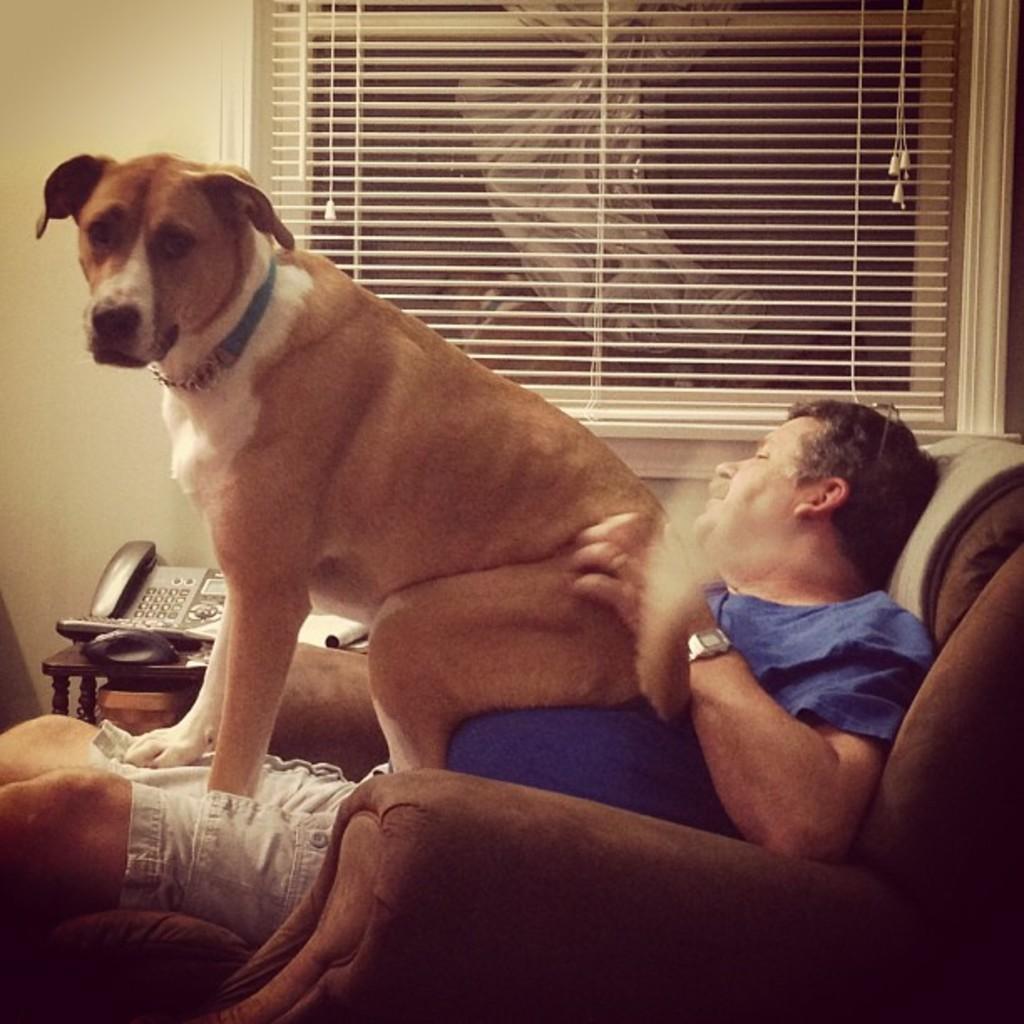How would you summarize this image in a sentence or two? In this picture we can see a man and woman sitting on sofa and on him dog is sitting and beside to them we have a telephone, book on table and in the background we can see wall, window with curtain. 